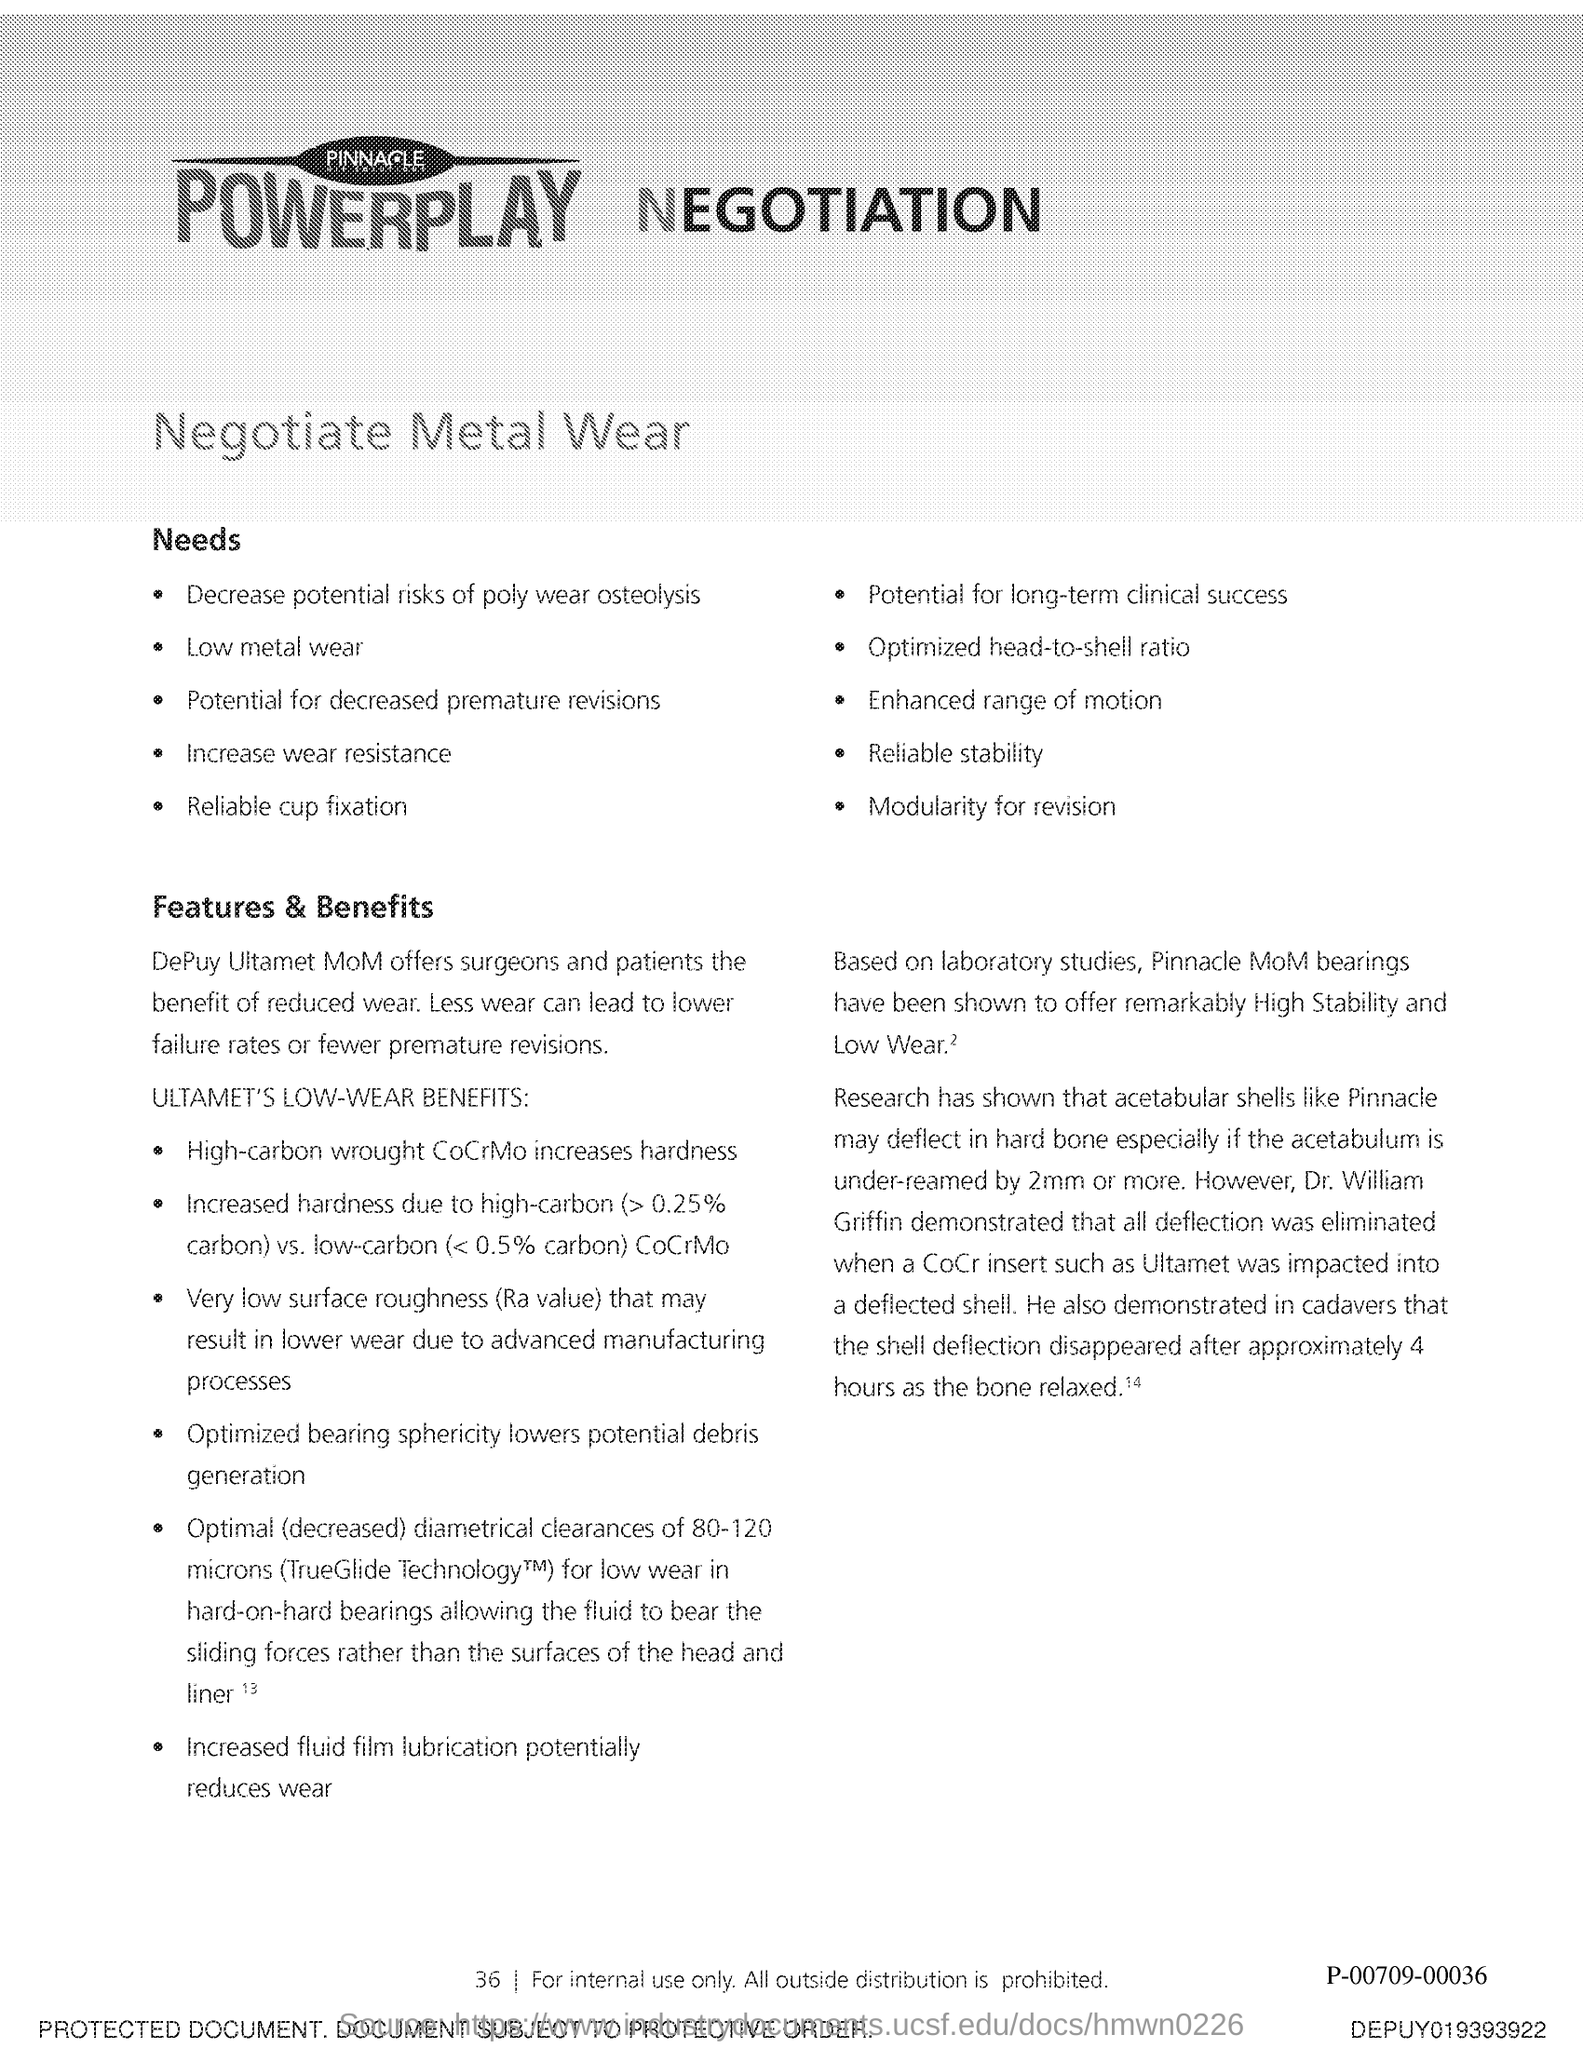Give some essential details in this illustration. DePuy Ultamet Metal on Metal hip implants offer surgeons and patients the advantage of reduced wear, leading to improved implant longevity and patient outcomes. Increased fluid film lubrication has the potential to reduce wear. 